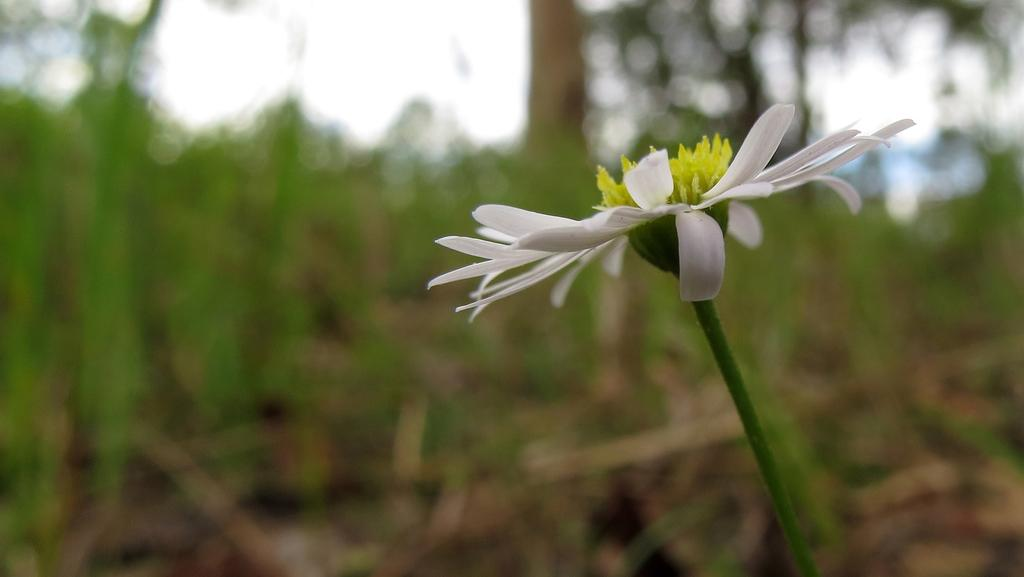What is the main subject of the image? There is a flower in the image. Can you describe the background of the image? The background of the image is blurred. How many ants are crawling on the cart in the image? There is no cart or ants present in the image; it features a flower with a blurred background. What type of road can be seen in the image? There is no road present in the image; it features a flower with a blurred background. 